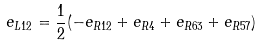Convert formula to latex. <formula><loc_0><loc_0><loc_500><loc_500>e _ { L 1 2 } = \frac { 1 } { 2 } ( - e _ { R 1 2 } + e _ { R 4 } + e _ { R 6 3 } + e _ { R 5 7 } )</formula> 